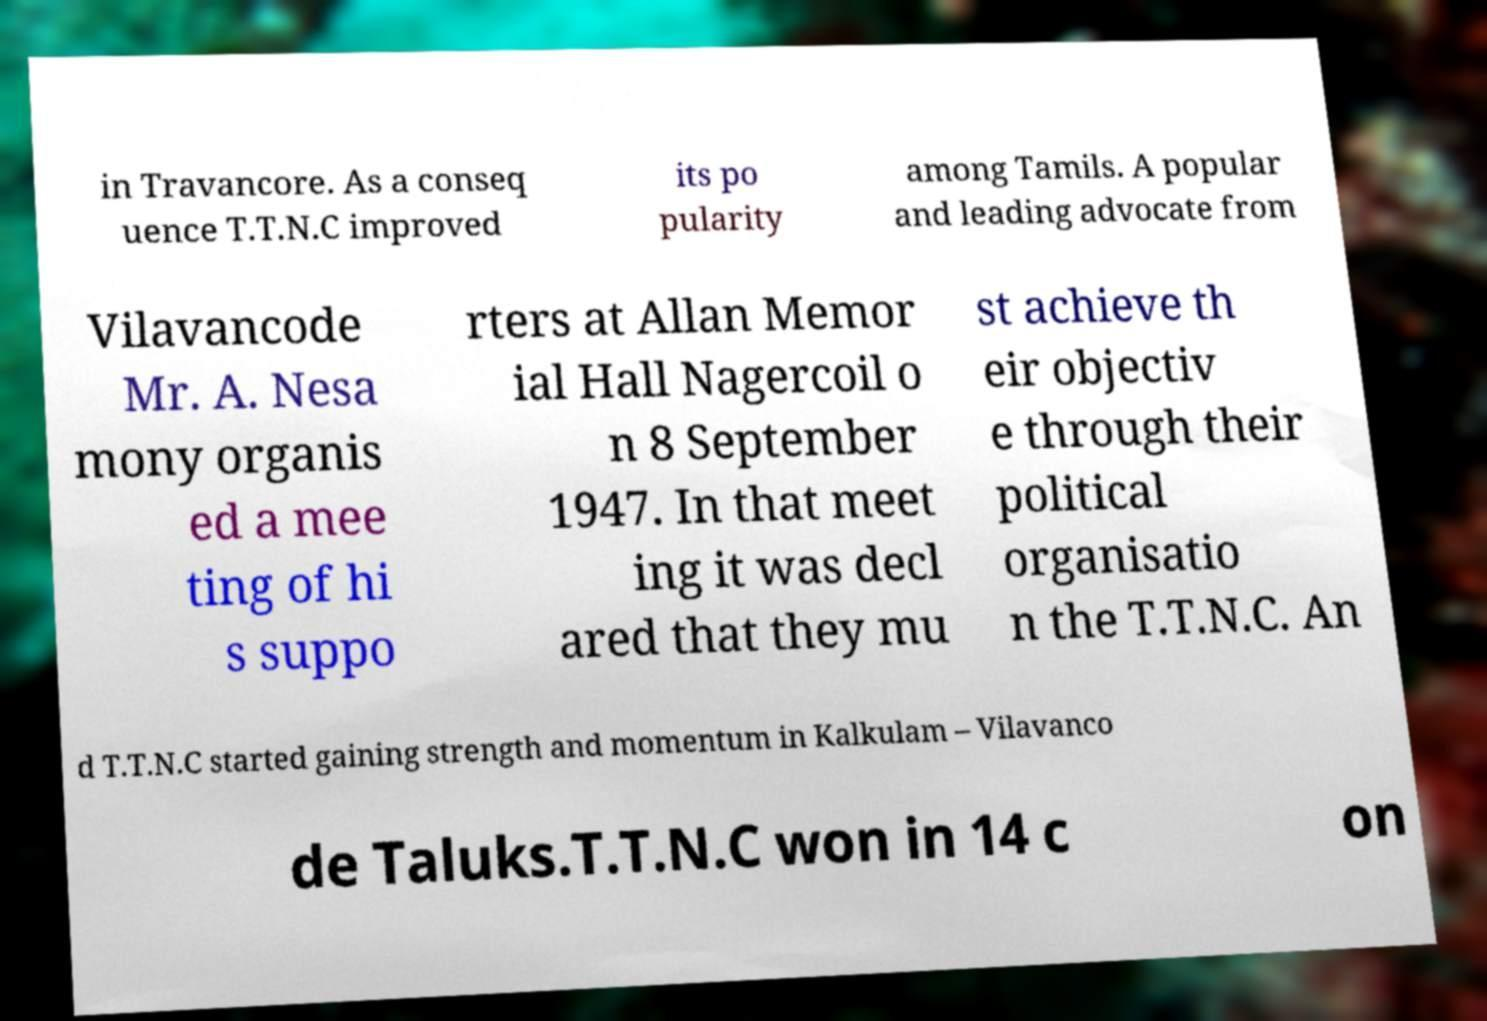Can you read and provide the text displayed in the image?This photo seems to have some interesting text. Can you extract and type it out for me? in Travancore. As a conseq uence T.T.N.C improved its po pularity among Tamils. A popular and leading advocate from Vilavancode Mr. A. Nesa mony organis ed a mee ting of hi s suppo rters at Allan Memor ial Hall Nagercoil o n 8 September 1947. In that meet ing it was decl ared that they mu st achieve th eir objectiv e through their political organisatio n the T.T.N.C. An d T.T.N.C started gaining strength and momentum in Kalkulam – Vilavanco de Taluks.T.T.N.C won in 14 c on 